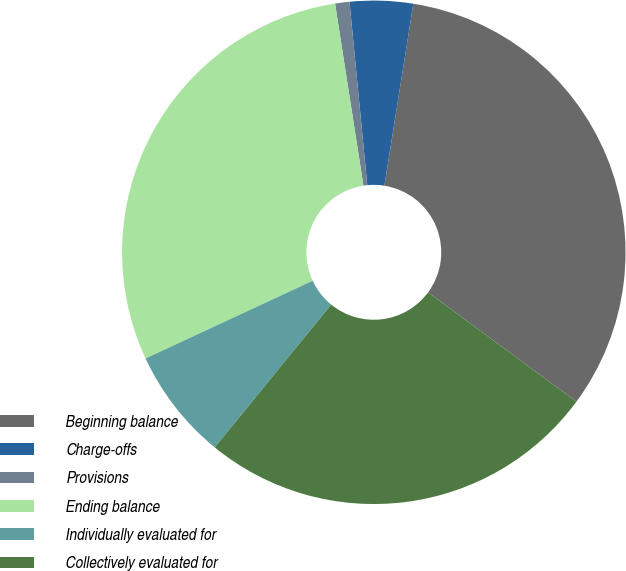Convert chart. <chart><loc_0><loc_0><loc_500><loc_500><pie_chart><fcel>Beginning balance<fcel>Charge-offs<fcel>Provisions<fcel>Ending balance<fcel>Individually evaluated for<fcel>Collectively evaluated for<nl><fcel>32.6%<fcel>4.05%<fcel>0.92%<fcel>29.47%<fcel>7.18%<fcel>25.78%<nl></chart> 